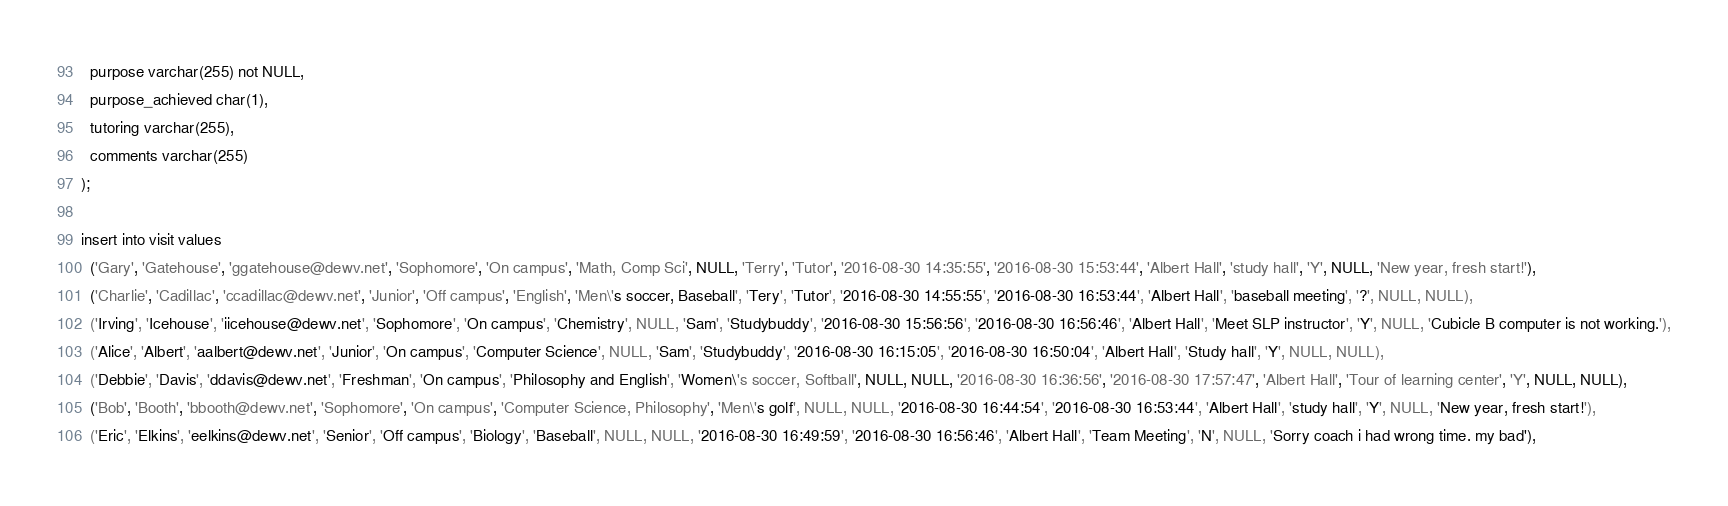Convert code to text. <code><loc_0><loc_0><loc_500><loc_500><_SQL_>  purpose varchar(255) not NULL,
  purpose_achieved char(1),
  tutoring varchar(255),
  comments varchar(255)
);

insert into visit values 
  ('Gary', 'Gatehouse', 'ggatehouse@dewv.net', 'Sophomore', 'On campus', 'Math, Comp Sci', NULL, 'Terry', 'Tutor', '2016-08-30 14:35:55', '2016-08-30 15:53:44', 'Albert Hall', 'study hall', 'Y', NULL, 'New year, fresh start!'),
  ('Charlie', 'Cadillac', 'ccadillac@dewv.net', 'Junior', 'Off campus', 'English', 'Men\'s soccer, Baseball', 'Tery', 'Tutor', '2016-08-30 14:55:55', '2016-08-30 16:53:44', 'Albert Hall', 'baseball meeting', '?', NULL, NULL),
  ('Irving', 'Icehouse', 'iicehouse@dewv.net', 'Sophomore', 'On campus', 'Chemistry', NULL, 'Sam', 'Studybuddy', '2016-08-30 15:56:56', '2016-08-30 16:56:46', 'Albert Hall', 'Meet SLP instructor', 'Y', NULL, 'Cubicle B computer is not working.'),
  ('Alice', 'Albert', 'aalbert@dewv.net', 'Junior', 'On campus', 'Computer Science', NULL, 'Sam', 'Studybuddy', '2016-08-30 16:15:05', '2016-08-30 16:50:04', 'Albert Hall', 'Study hall', 'Y', NULL, NULL),
  ('Debbie', 'Davis', 'ddavis@dewv.net', 'Freshman', 'On campus', 'Philosophy and English', 'Women\'s soccer, Softball', NULL, NULL, '2016-08-30 16:36:56', '2016-08-30 17:57:47', 'Albert Hall', 'Tour of learning center', 'Y', NULL, NULL),
  ('Bob', 'Booth', 'bbooth@dewv.net', 'Sophomore', 'On campus', 'Computer Science, Philosophy', 'Men\'s golf', NULL, NULL, '2016-08-30 16:44:54', '2016-08-30 16:53:44', 'Albert Hall', 'study hall', 'Y', NULL, 'New year, fresh start!'),
  ('Eric', 'Elkins', 'eelkins@dewv.net', 'Senior', 'Off campus', 'Biology', 'Baseball', NULL, NULL, '2016-08-30 16:49:59', '2016-08-30 16:56:46', 'Albert Hall', 'Team Meeting', 'N', NULL, 'Sorry coach i had wrong time. my bad'),</code> 